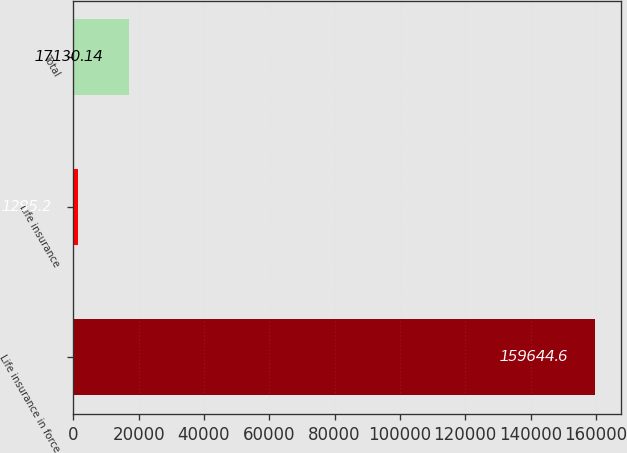<chart> <loc_0><loc_0><loc_500><loc_500><bar_chart><fcel>Life insurance in force<fcel>Life insurance<fcel>Total<nl><fcel>159645<fcel>1295.2<fcel>17130.1<nl></chart> 